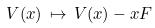<formula> <loc_0><loc_0><loc_500><loc_500>V ( x ) \, \mapsto \, V ( x ) - x F</formula> 